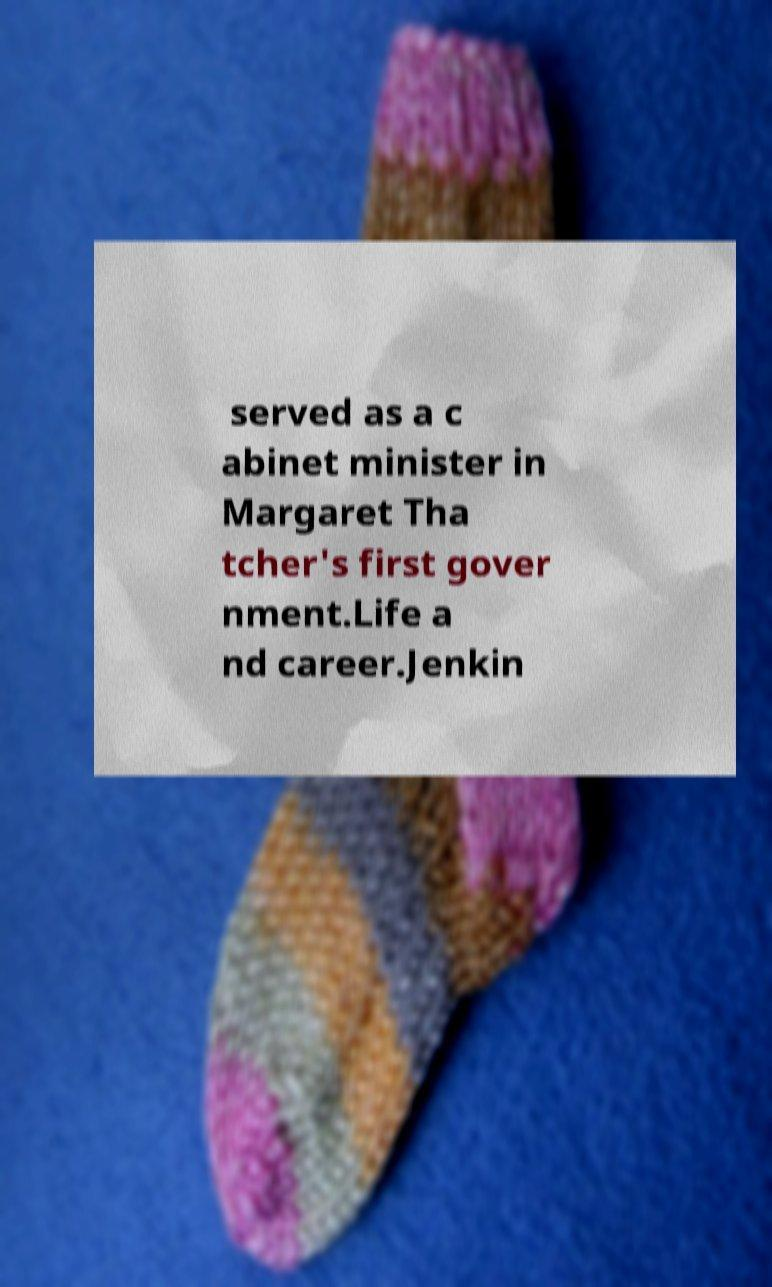Please identify and transcribe the text found in this image. served as a c abinet minister in Margaret Tha tcher's first gover nment.Life a nd career.Jenkin 